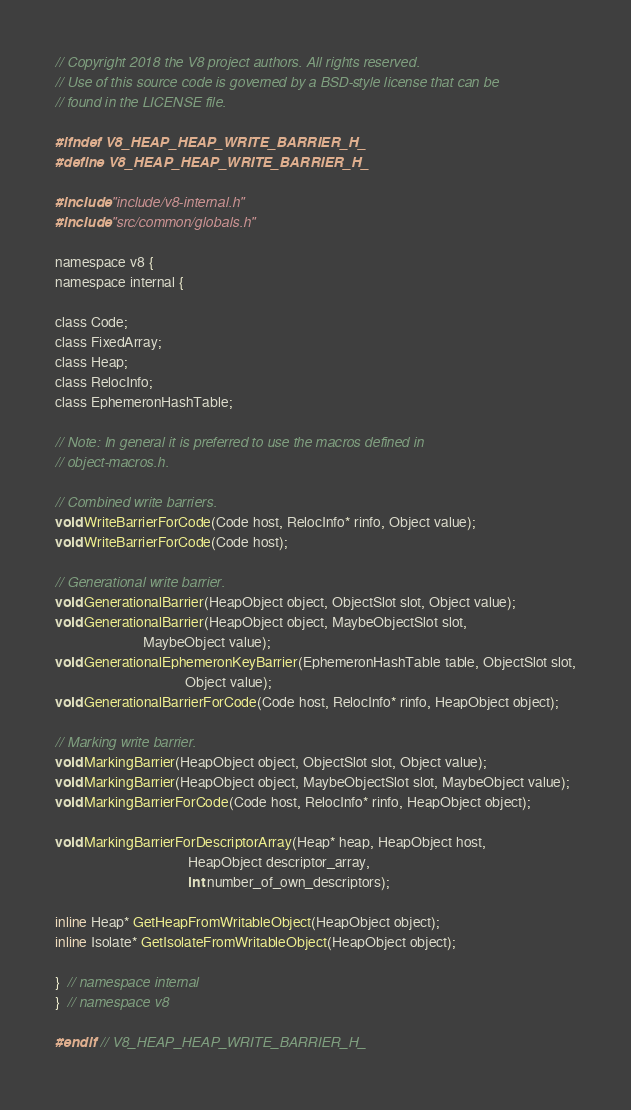<code> <loc_0><loc_0><loc_500><loc_500><_C_>// Copyright 2018 the V8 project authors. All rights reserved.
// Use of this source code is governed by a BSD-style license that can be
// found in the LICENSE file.

#ifndef V8_HEAP_HEAP_WRITE_BARRIER_H_
#define V8_HEAP_HEAP_WRITE_BARRIER_H_

#include "include/v8-internal.h"
#include "src/common/globals.h"

namespace v8 {
namespace internal {

class Code;
class FixedArray;
class Heap;
class RelocInfo;
class EphemeronHashTable;

// Note: In general it is preferred to use the macros defined in
// object-macros.h.

// Combined write barriers.
void WriteBarrierForCode(Code host, RelocInfo* rinfo, Object value);
void WriteBarrierForCode(Code host);

// Generational write barrier.
void GenerationalBarrier(HeapObject object, ObjectSlot slot, Object value);
void GenerationalBarrier(HeapObject object, MaybeObjectSlot slot,
                         MaybeObject value);
void GenerationalEphemeronKeyBarrier(EphemeronHashTable table, ObjectSlot slot,
                                     Object value);
void GenerationalBarrierForCode(Code host, RelocInfo* rinfo, HeapObject object);

// Marking write barrier.
void MarkingBarrier(HeapObject object, ObjectSlot slot, Object value);
void MarkingBarrier(HeapObject object, MaybeObjectSlot slot, MaybeObject value);
void MarkingBarrierForCode(Code host, RelocInfo* rinfo, HeapObject object);

void MarkingBarrierForDescriptorArray(Heap* heap, HeapObject host,
                                      HeapObject descriptor_array,
                                      int number_of_own_descriptors);

inline Heap* GetHeapFromWritableObject(HeapObject object);
inline Isolate* GetIsolateFromWritableObject(HeapObject object);

}  // namespace internal
}  // namespace v8

#endif  // V8_HEAP_HEAP_WRITE_BARRIER_H_
</code> 